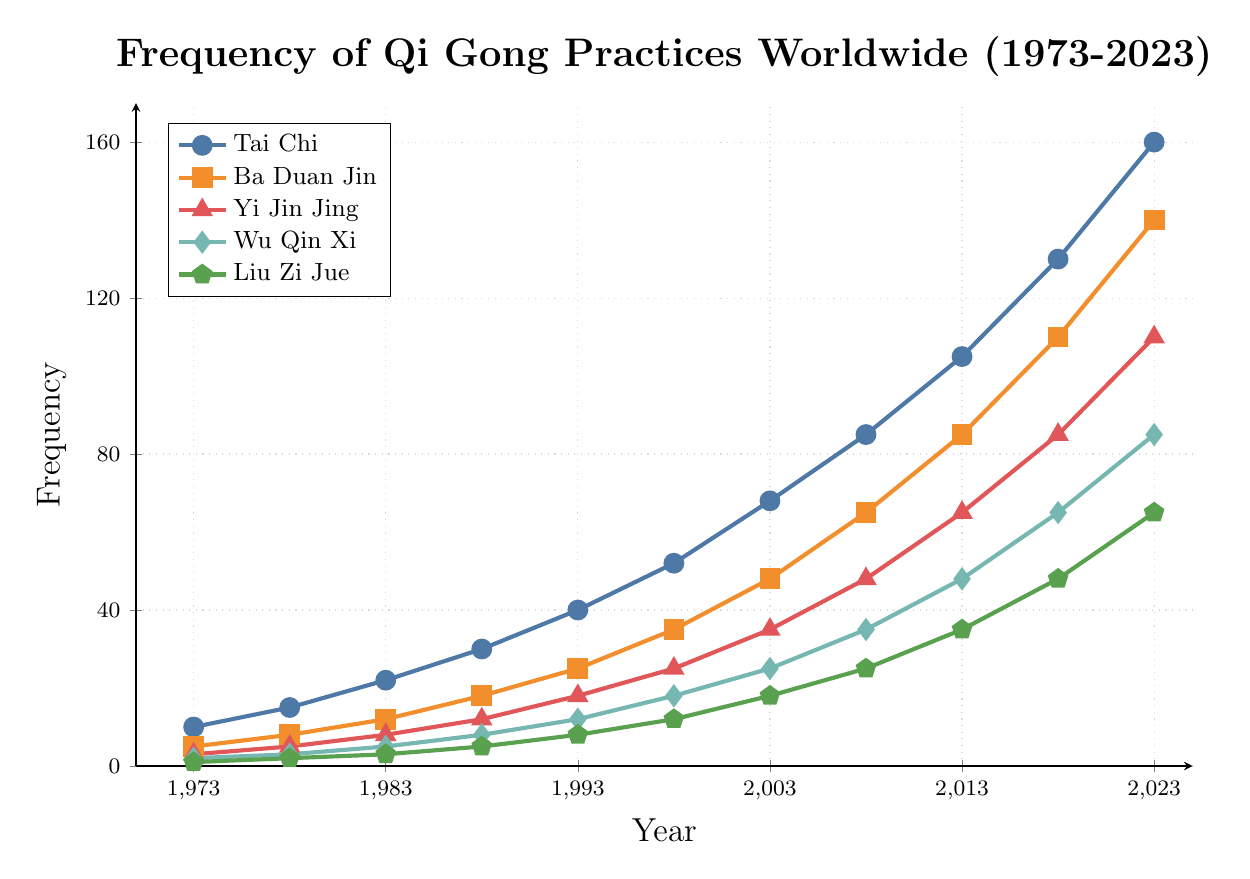What is the difference in the frequency of Tai Chi between 1973 and 2023? To calculate the difference in frequency, subtract the frequency in 1973 from the frequency in 2023. The frequency of Tai Chi in 1973 is 10, and in 2023 it is 160. So, 160 - 10 = 150.
Answer: 150 Which Qi Gong practice has the highest frequency in 2013? Look at the line chart for the year 2013 and identify the practice with the highest value. Tai Chi has a frequency of 105, which is the highest among all practices.
Answer: Tai Chi How many more people practiced Ba Duan Jin compared to Wu Qin Xi in 2008? Find the frequency of Ba Duan Jin and Wu Qin Xi in 2008. Ba Duan Jin has a frequency of 65, and Wu Qin Xi has a frequency of 35. Subtract the frequency of Wu Qin Xi from Ba Duan Jin: 65 - 35 = 30.
Answer: 30 What is the average yearly increase in frequency for Yi Jin Jing from 1973 to 2023? First, find the total increase by subtracting the 1973 frequency from the 2023 frequency. The frequency of Yi Jin Jing in 2023 is 110, and in 1973 it is 3. So, 110 - 3 = 107. There are 2023 - 1973 = 50 years. The average yearly increase is 107 / 50 = 2.14.
Answer: 2.14 Which practice surpassed a frequency of 100 first, and in which year? Identify when each practice first surpassed 100 by looking at the data points on the chart. Tai Chi surpassed 100 first in 2013, with a frequency of 105.
Answer: Tai Chi in 2013 Describe the trend for Liu Zi Jue from 1973 to 2023. Observe the line for Liu Zi Jue across the years 1973 to 2023. The frequency increases constantly, starting at 1 in 1973 and reaching 65 in 2023. The trend is a steady increase over time.
Answer: Steady increase 